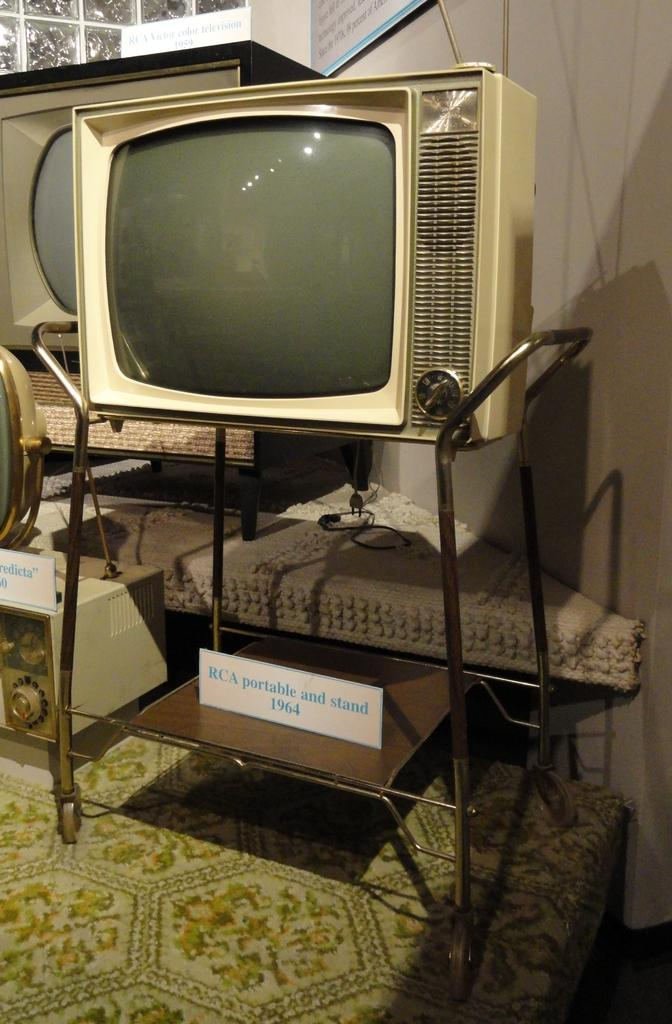<image>
Offer a succinct explanation of the picture presented. the word portable is on the white sign 